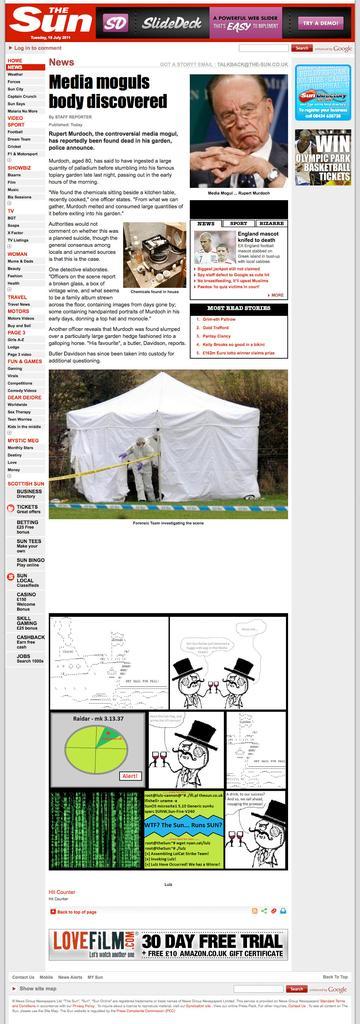Please provide a concise description of this image. In the picture we can see a magazine with some information and some images and on the top of it we can see a advertisement the sun. 